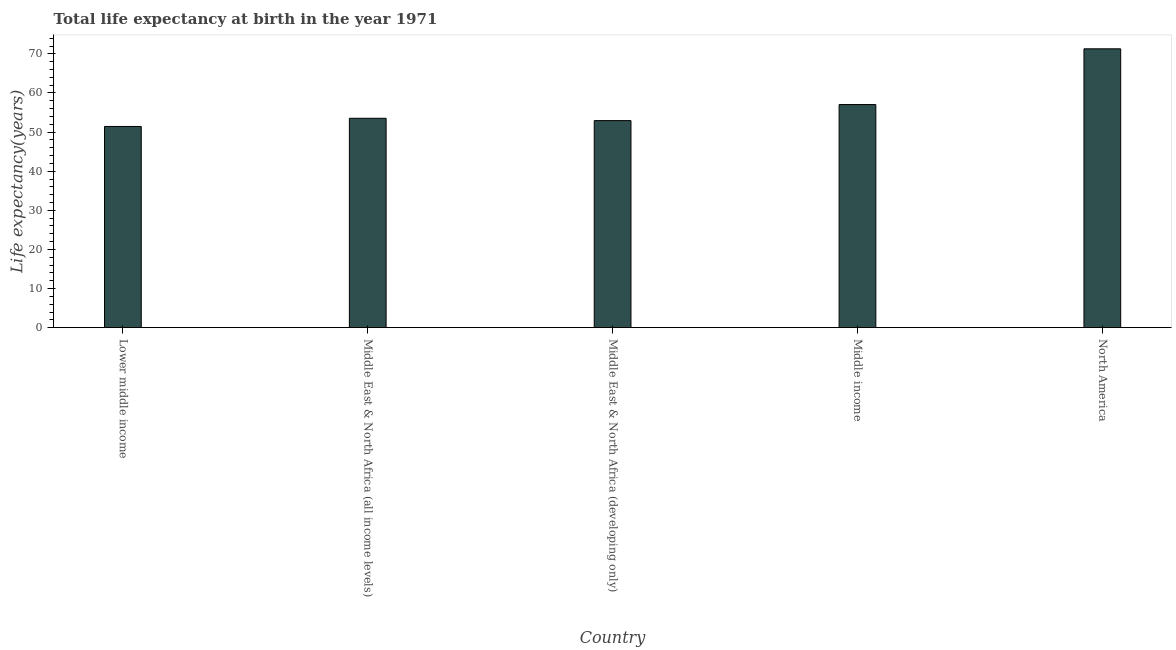Does the graph contain grids?
Offer a terse response. No. What is the title of the graph?
Ensure brevity in your answer.  Total life expectancy at birth in the year 1971. What is the label or title of the Y-axis?
Make the answer very short. Life expectancy(years). What is the life expectancy at birth in North America?
Offer a terse response. 71.29. Across all countries, what is the maximum life expectancy at birth?
Keep it short and to the point. 71.29. Across all countries, what is the minimum life expectancy at birth?
Provide a short and direct response. 51.44. In which country was the life expectancy at birth maximum?
Offer a very short reply. North America. In which country was the life expectancy at birth minimum?
Give a very brief answer. Lower middle income. What is the sum of the life expectancy at birth?
Your answer should be compact. 286.23. What is the difference between the life expectancy at birth in Middle East & North Africa (all income levels) and Middle East & North Africa (developing only)?
Offer a terse response. 0.6. What is the average life expectancy at birth per country?
Provide a short and direct response. 57.25. What is the median life expectancy at birth?
Provide a short and direct response. 53.53. What is the ratio of the life expectancy at birth in Middle East & North Africa (developing only) to that in Middle income?
Provide a short and direct response. 0.93. What is the difference between the highest and the second highest life expectancy at birth?
Your answer should be compact. 14.25. Is the sum of the life expectancy at birth in Middle East & North Africa (all income levels) and North America greater than the maximum life expectancy at birth across all countries?
Provide a succinct answer. Yes. What is the difference between the highest and the lowest life expectancy at birth?
Offer a terse response. 19.85. How many bars are there?
Provide a succinct answer. 5. What is the difference between two consecutive major ticks on the Y-axis?
Offer a terse response. 10. What is the Life expectancy(years) of Lower middle income?
Offer a terse response. 51.44. What is the Life expectancy(years) of Middle East & North Africa (all income levels)?
Your response must be concise. 53.53. What is the Life expectancy(years) in Middle East & North Africa (developing only)?
Your answer should be compact. 52.93. What is the Life expectancy(years) of Middle income?
Provide a short and direct response. 57.04. What is the Life expectancy(years) of North America?
Your response must be concise. 71.29. What is the difference between the Life expectancy(years) in Lower middle income and Middle East & North Africa (all income levels)?
Provide a succinct answer. -2.09. What is the difference between the Life expectancy(years) in Lower middle income and Middle East & North Africa (developing only)?
Offer a terse response. -1.49. What is the difference between the Life expectancy(years) in Lower middle income and Middle income?
Provide a succinct answer. -5.6. What is the difference between the Life expectancy(years) in Lower middle income and North America?
Your answer should be compact. -19.85. What is the difference between the Life expectancy(years) in Middle East & North Africa (all income levels) and Middle East & North Africa (developing only)?
Offer a terse response. 0.6. What is the difference between the Life expectancy(years) in Middle East & North Africa (all income levels) and Middle income?
Keep it short and to the point. -3.51. What is the difference between the Life expectancy(years) in Middle East & North Africa (all income levels) and North America?
Provide a short and direct response. -17.76. What is the difference between the Life expectancy(years) in Middle East & North Africa (developing only) and Middle income?
Give a very brief answer. -4.11. What is the difference between the Life expectancy(years) in Middle East & North Africa (developing only) and North America?
Make the answer very short. -18.35. What is the difference between the Life expectancy(years) in Middle income and North America?
Offer a very short reply. -14.25. What is the ratio of the Life expectancy(years) in Lower middle income to that in Middle East & North Africa (all income levels)?
Make the answer very short. 0.96. What is the ratio of the Life expectancy(years) in Lower middle income to that in Middle income?
Ensure brevity in your answer.  0.9. What is the ratio of the Life expectancy(years) in Lower middle income to that in North America?
Make the answer very short. 0.72. What is the ratio of the Life expectancy(years) in Middle East & North Africa (all income levels) to that in Middle East & North Africa (developing only)?
Your answer should be very brief. 1.01. What is the ratio of the Life expectancy(years) in Middle East & North Africa (all income levels) to that in Middle income?
Keep it short and to the point. 0.94. What is the ratio of the Life expectancy(years) in Middle East & North Africa (all income levels) to that in North America?
Make the answer very short. 0.75. What is the ratio of the Life expectancy(years) in Middle East & North Africa (developing only) to that in Middle income?
Provide a short and direct response. 0.93. What is the ratio of the Life expectancy(years) in Middle East & North Africa (developing only) to that in North America?
Offer a terse response. 0.74. 